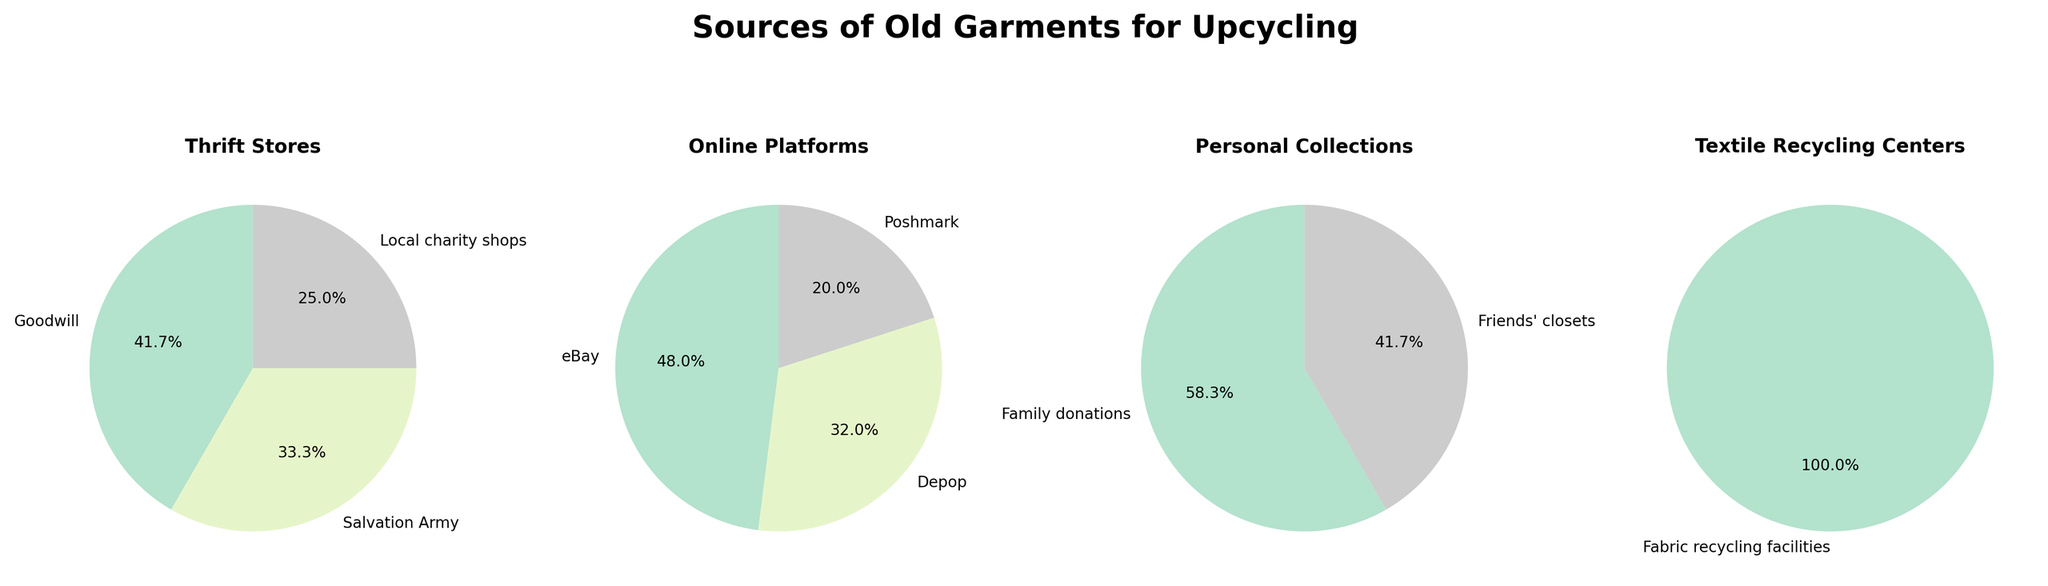How many sources are listed under the "Online Platforms" category? Count the number of pie slices in the "Online Platforms" pie chart. There are three sources: eBay, Depop, and Poshmark.
Answer: 3 What's the largest source of old garments from "Thrift Stores"? Identify the pie slice with the largest percentage in the "Thrift Stores" pie chart. The largest source is Goodwill at 25%.
Answer: Goodwill Which category has the smallest individual percentage slice and what is it? Locate the smallest percentage slice among all pie charts. Textile Recycling Centers have the smallest slice, which is Fabric recycling facilities at 3%.
Answer: Textile Recycling Centers (3%) How do the percentages of family donations and friends' closets compare? Compare the percentages of "Family donations" and "Friends' closets" in the "Personal Collections" pie chart. Family donations account for 7%, while friends' closets account for 5%. Family donations have a larger percentage.
Answer: Family donations > Friends' closets What is the combined percentage of "Thrift Stores" sources? Add the percentages of all slices in the "Thrift Stores" pie chart. Goodwill: 25%, Salvation Army: 20%, Local charity shops: 15%. Their sum is 25% + 20% + 15% = 60%.
Answer: 60% Which source is the second largest in the "Online Platforms" category? Rank the slices in the "Online Platforms" pie chart by percentage. The second largest is Depop at 8%.
Answer: Depop What is the difference in percentage between "eBay" and "Poshmark"? Subtract the percentage of Poshmark from the percentage of eBay in the "Online Platforms" pie chart. eBay: 12%, Poshmark: 5%. The difference is 12% - 5% = 7%.
Answer: 7% Which category has the highest number of sources? Compare the number of sources within each category's pie chart. "Thrift Stores" has three sources: Goodwill, Salvation Army, and Local charity shops.
Answer: Thrift Stores What is the total percentage of sources from "Personal Collections"? Add the percentages of "Family donations" and "Friends' closets" from the "Personal Collections" pie chart. Family donations: 7%, Friends' closets: 5%. Their sum is 7% + 5% = 12%.
Answer: 12% 